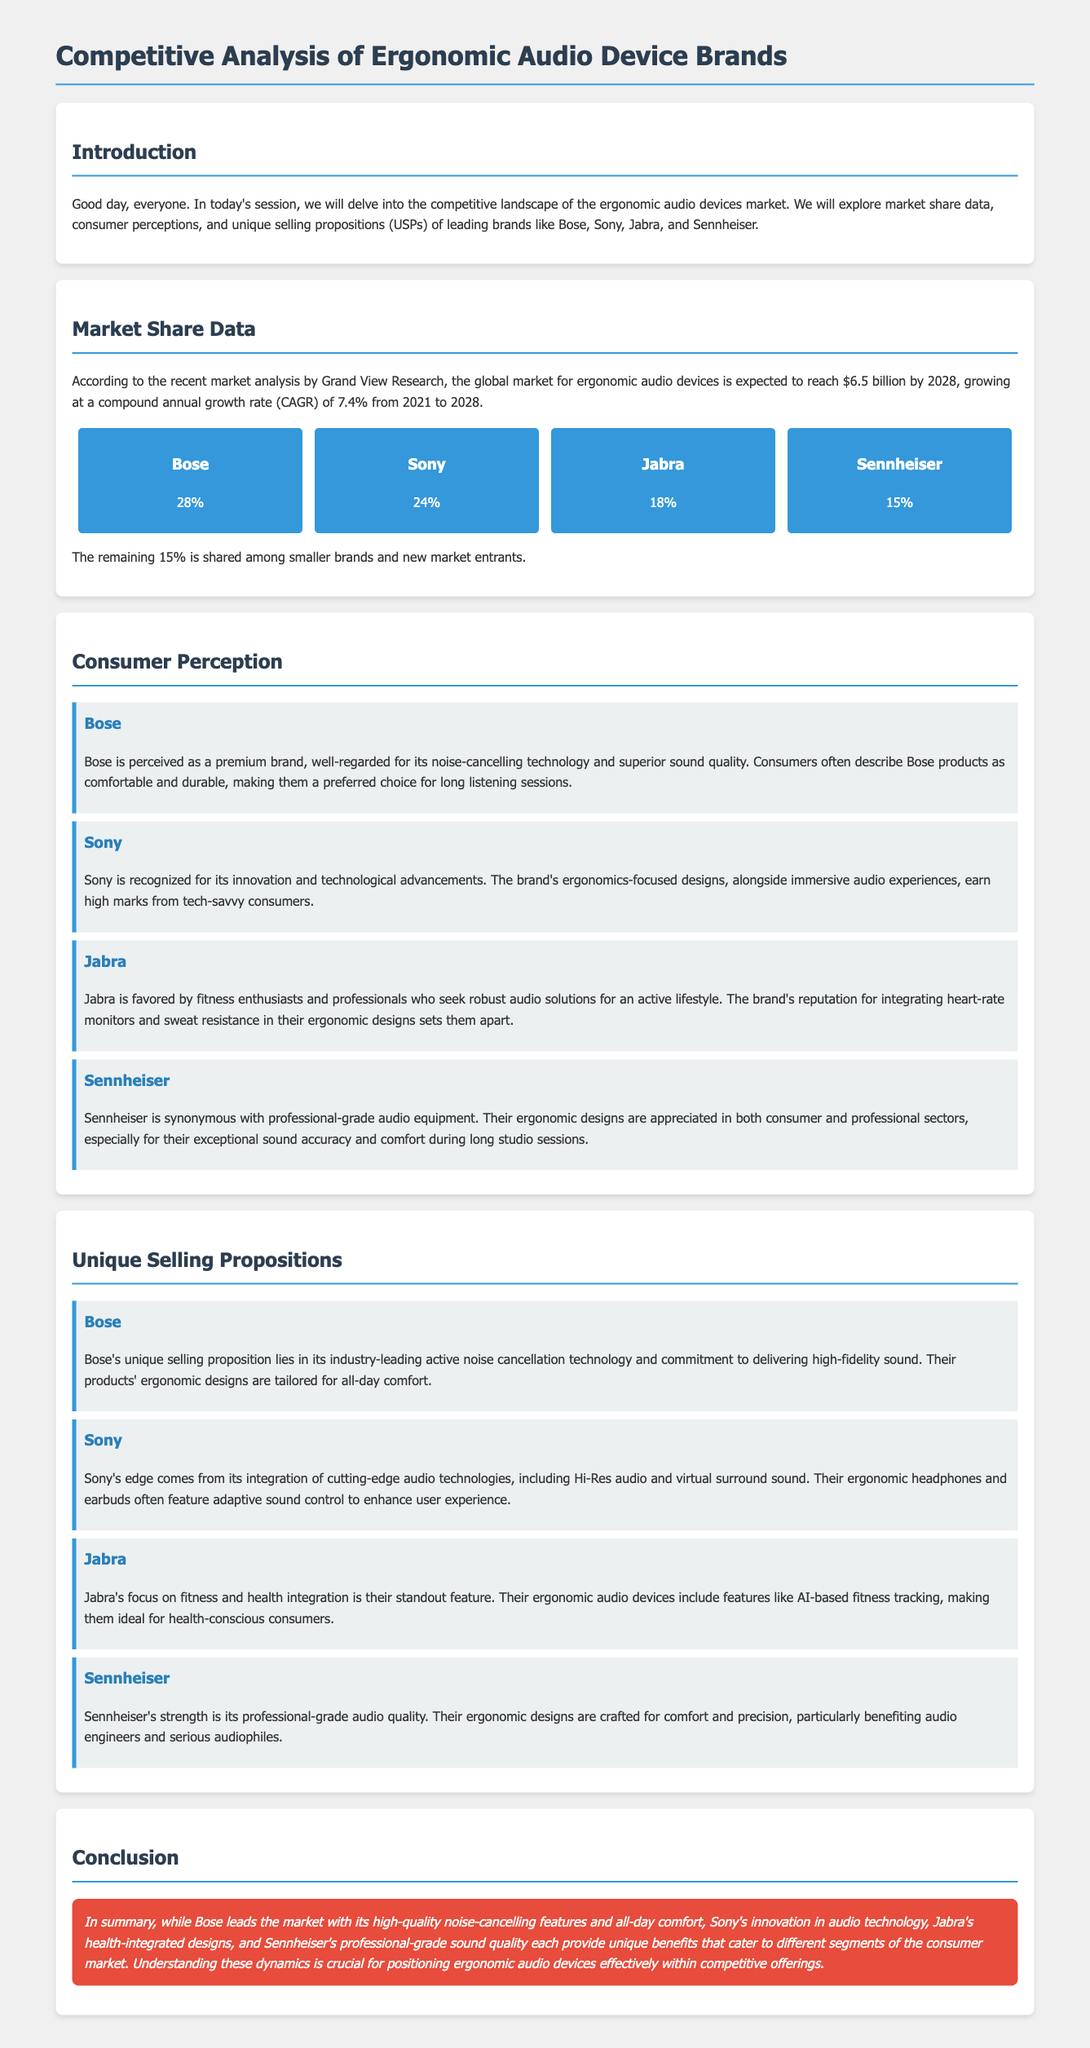what is the projected market size for ergonomic audio devices by 2028? The document states the global market for ergonomic audio devices is expected to reach $6.5 billion by 2028.
Answer: $6.5 billion what is Bose’s market share percentage? The document lists Bose's market share as 28%.
Answer: 28% what brand is favored by fitness enthusiasts? The document indicates that Jabra is favored by fitness enthusiasts and professionals.
Answer: Jabra which brand is well-regarded for its noise-cancelling technology? According to the document, Bose is perceived as a premium brand well-regarded for its noise-cancelling technology.
Answer: Bose what unique selling proposition does Sony offer? The document describes Sony's unique selling proposition as integration of cutting-edge audio technologies, including Hi-Res audio and virtual surround sound.
Answer: Hi-Res audio and virtual surround sound which brand is synonymous with professional-grade audio equipment? The document states that Sennheiser is synonymous with professional-grade audio equipment.
Answer: Sennheiser what is the remaining market share percentage shared by smaller brands? The document mentions that the remaining 15% is shared among smaller brands and new market entrants.
Answer: 15% which brand focuses on health integration in their audio devices? The document reveals that Jabra focuses on fitness and health integration in their audio devices.
Answer: Jabra 